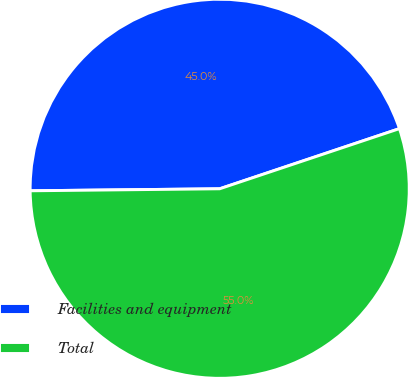Convert chart. <chart><loc_0><loc_0><loc_500><loc_500><pie_chart><fcel>Facilities and equipment<fcel>Total<nl><fcel>45.03%<fcel>54.97%<nl></chart> 